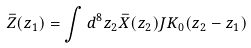Convert formula to latex. <formula><loc_0><loc_0><loc_500><loc_500>\bar { Z } ( z _ { 1 } ) = \int d ^ { 8 } z _ { 2 } \bar { X } ( z _ { 2 } ) J K _ { 0 } ( z _ { 2 } - z _ { 1 } )</formula> 